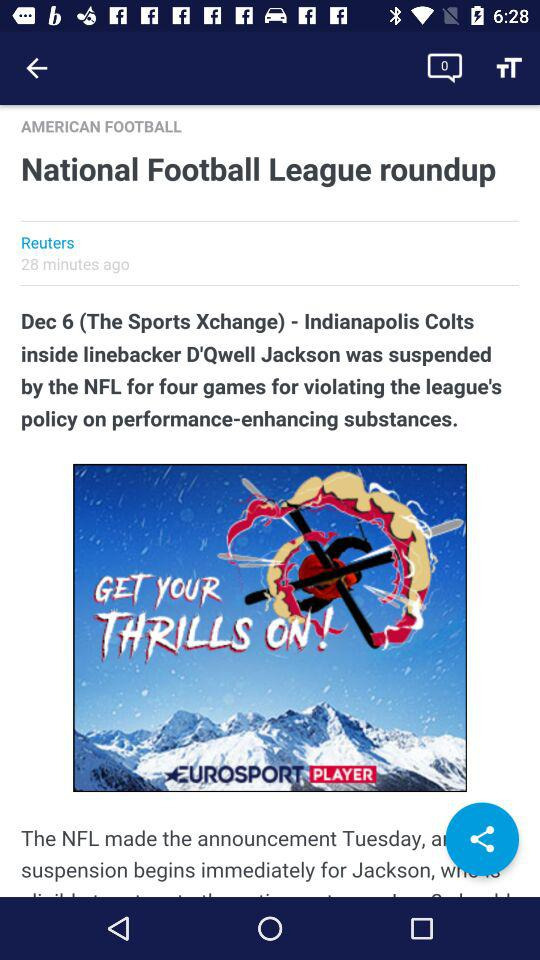What is the title of the article? The title is "National Football League roundup". 